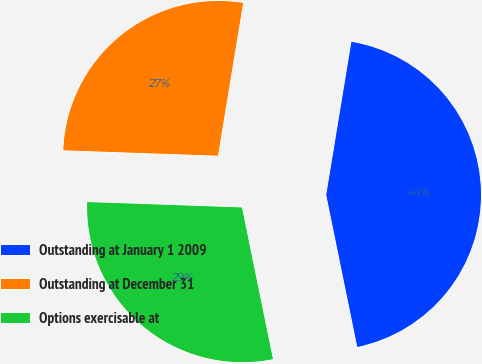<chart> <loc_0><loc_0><loc_500><loc_500><pie_chart><fcel>Outstanding at January 1 2009<fcel>Outstanding at December 31<fcel>Options exercisable at<nl><fcel>44.2%<fcel>27.04%<fcel>28.76%<nl></chart> 